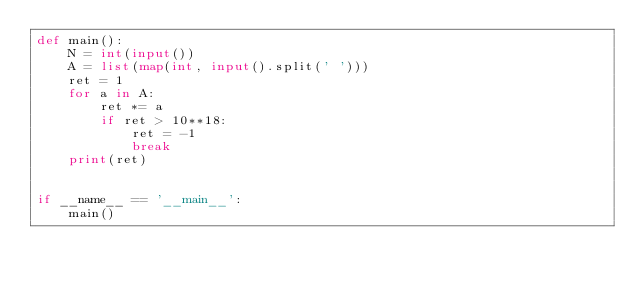<code> <loc_0><loc_0><loc_500><loc_500><_Python_>def main():
    N = int(input())
    A = list(map(int, input().split(' ')))
    ret = 1
    for a in A:
        ret *= a
        if ret > 10**18:
            ret = -1
            break
    print(ret)


if __name__ == '__main__':
    main()</code> 